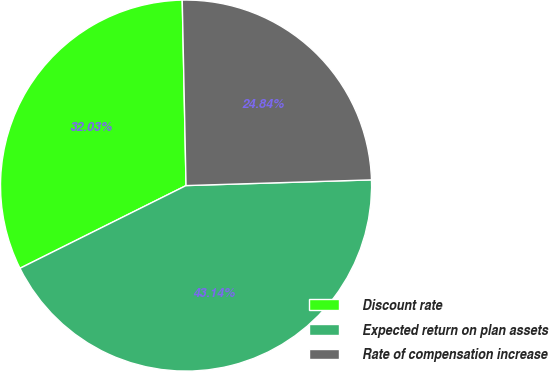Convert chart. <chart><loc_0><loc_0><loc_500><loc_500><pie_chart><fcel>Discount rate<fcel>Expected return on plan assets<fcel>Rate of compensation increase<nl><fcel>32.03%<fcel>43.14%<fcel>24.84%<nl></chart> 